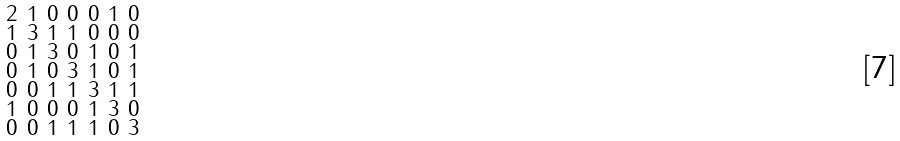Convert formula to latex. <formula><loc_0><loc_0><loc_500><loc_500>\begin{smallmatrix} 2 & 1 & 0 & 0 & 0 & 1 & 0 \\ 1 & 3 & 1 & 1 & 0 & 0 & 0 \\ 0 & 1 & 3 & 0 & 1 & 0 & 1 \\ 0 & 1 & 0 & 3 & 1 & 0 & 1 \\ 0 & 0 & 1 & 1 & 3 & 1 & 1 \\ 1 & 0 & 0 & 0 & 1 & 3 & 0 \\ 0 & 0 & 1 & 1 & 1 & 0 & 3 \end{smallmatrix}</formula> 